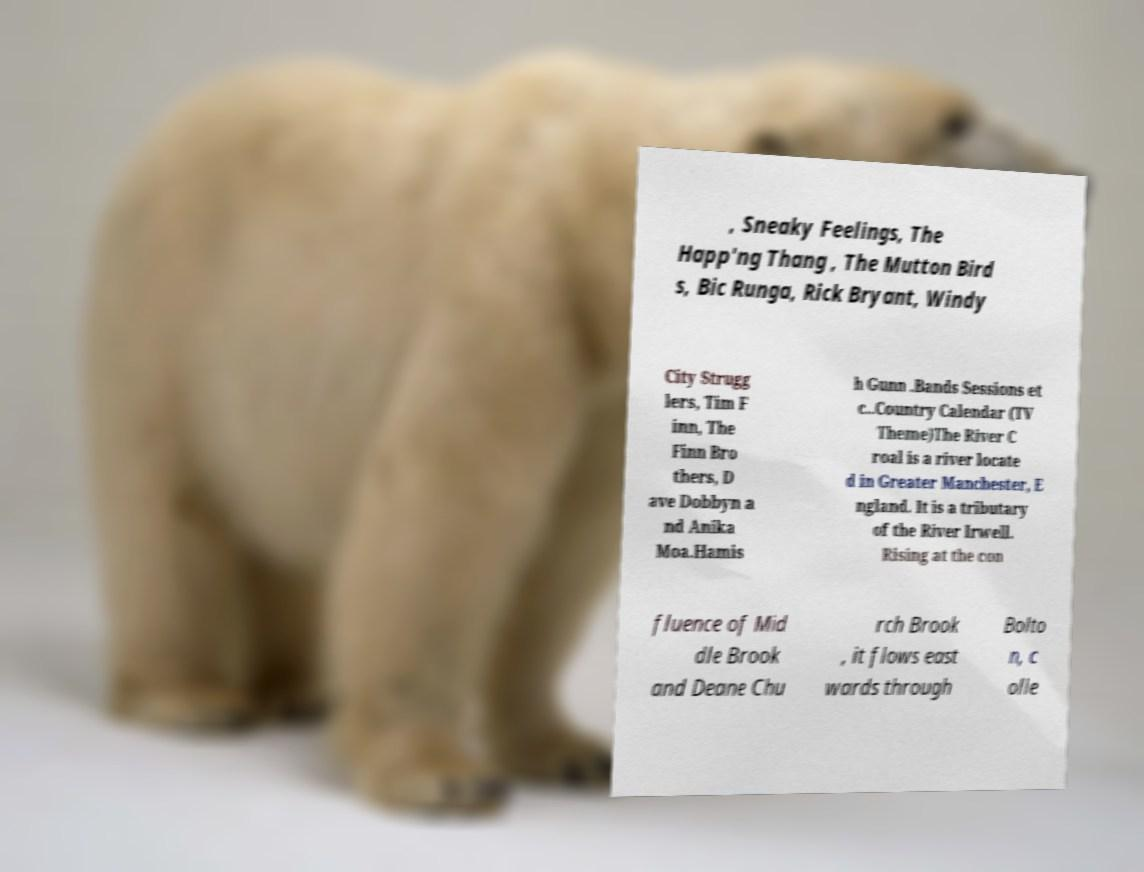Please read and relay the text visible in this image. What does it say? , Sneaky Feelings, The Happ'ng Thang , The Mutton Bird s, Bic Runga, Rick Bryant, Windy City Strugg lers, Tim F inn, The Finn Bro thers, D ave Dobbyn a nd Anika Moa.Hamis h Gunn .Bands Sessions et c..Country Calendar (TV Theme)The River C roal is a river locate d in Greater Manchester, E ngland. It is a tributary of the River Irwell. Rising at the con fluence of Mid dle Brook and Deane Chu rch Brook , it flows east wards through Bolto n, c olle 